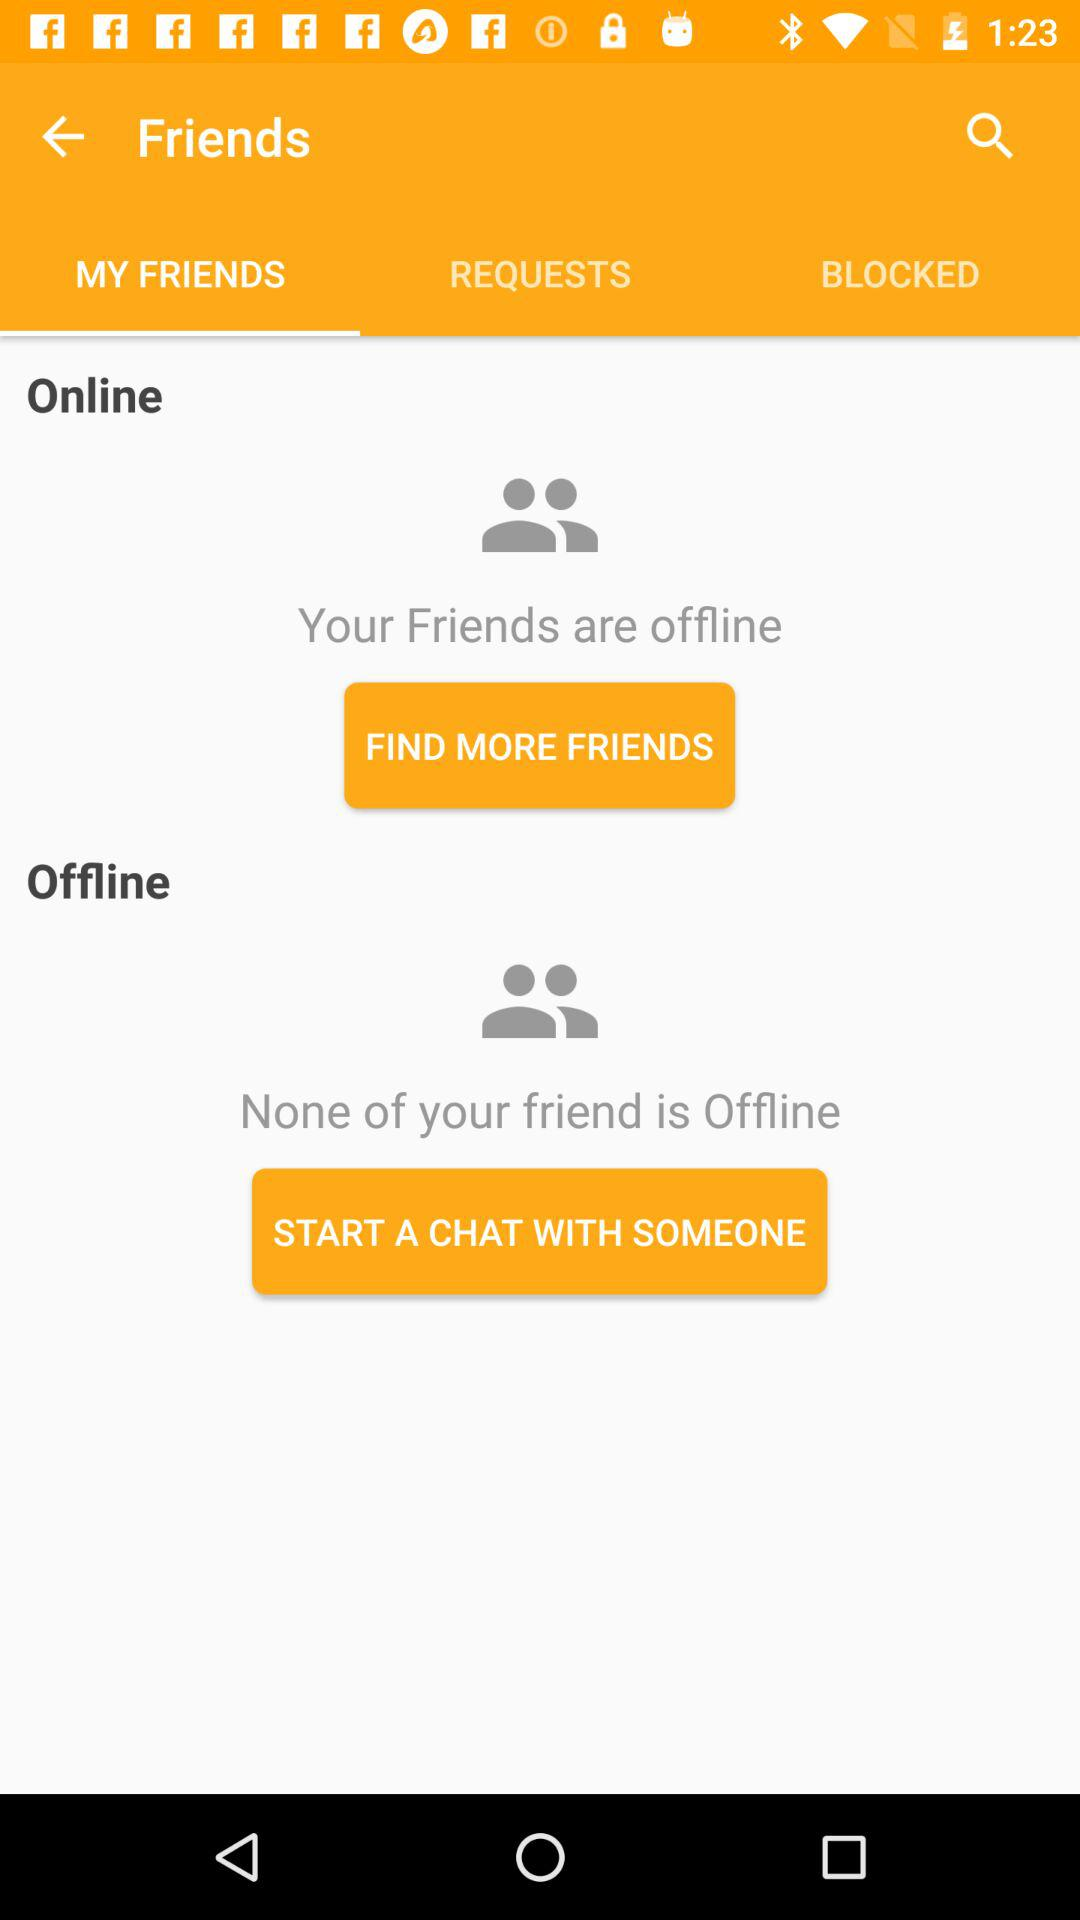Which option is selected? The selected option is "MY FRIENDS". 